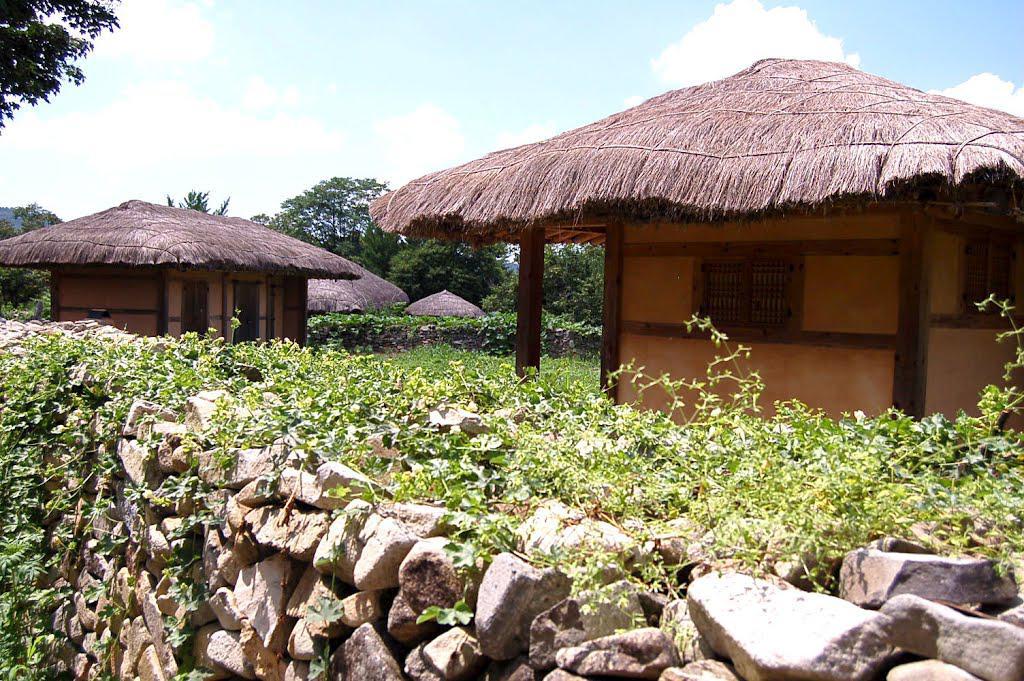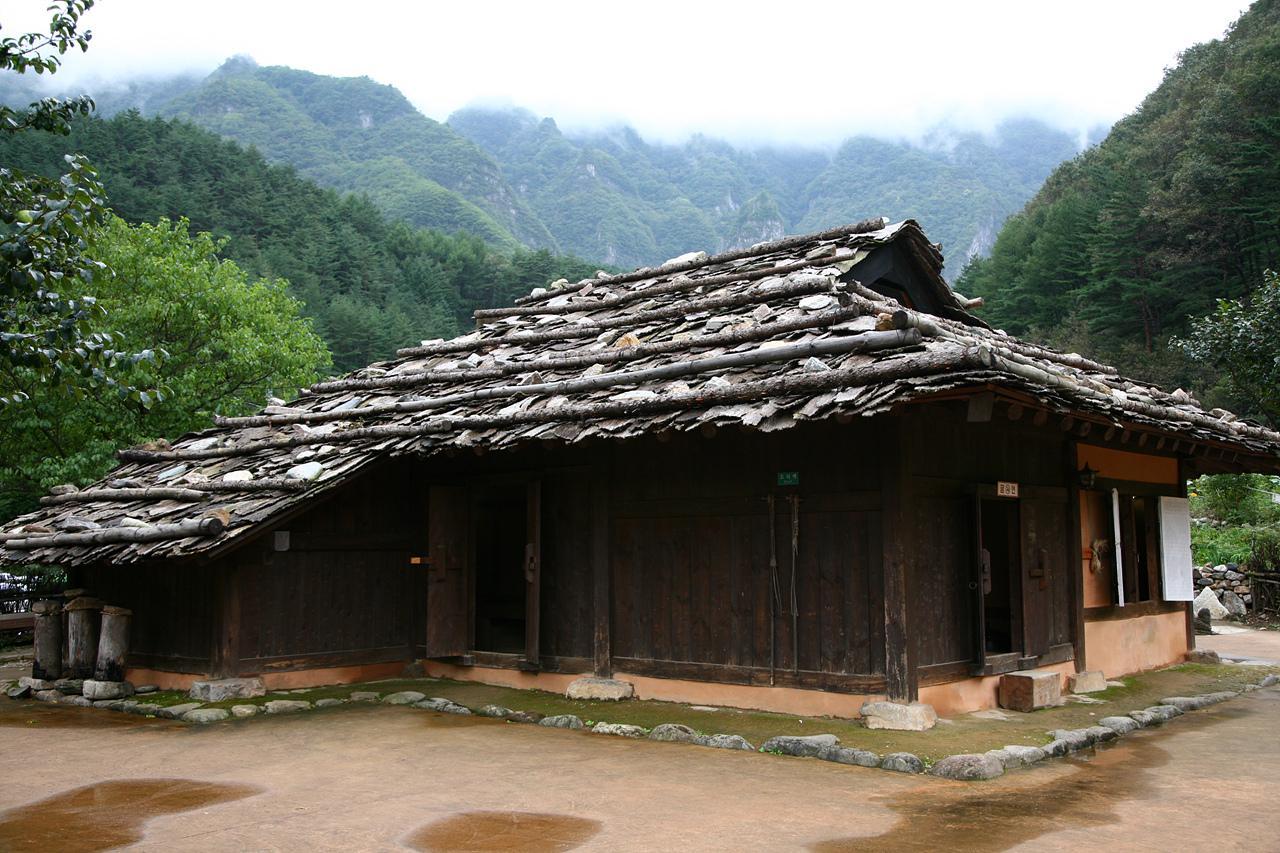The first image is the image on the left, the second image is the image on the right. Assess this claim about the two images: "In at least one image there is a hut with a roof made out of black straw.". Correct or not? Answer yes or no. No. The first image is the image on the left, the second image is the image on the right. For the images shown, is this caption "The left image shows a rock wall around at least one squarish building with smooth beige walls and a slightly peaked thatched roof." true? Answer yes or no. Yes. 